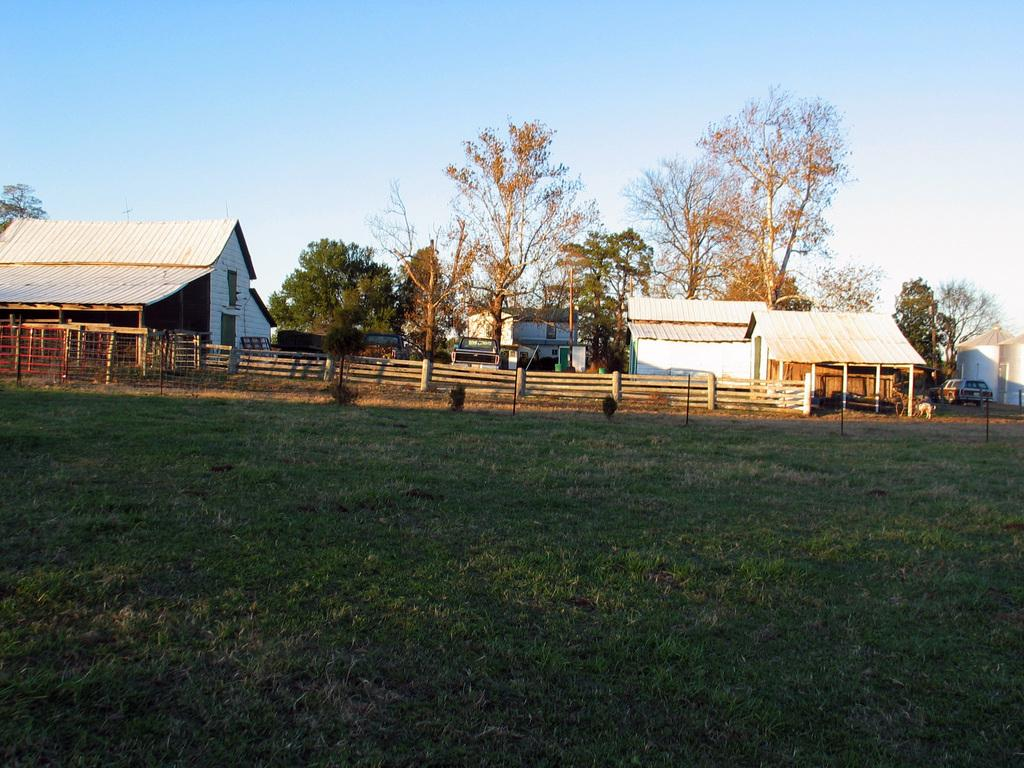What type of structures can be seen in the image? There are buildings and sheds in the image. What type of barrier is present in the image? There is a wooden fence in the image. What is visible on the ground in the image? The ground is visible in the image. What type of vegetation is present in the image? There are trees in the image. What type of transportation is present in the image? Motor vehicles are present in the image. What is visible in the sky in the image? The sky is visible in the image, and clouds are present. What type of rice is being cooked in the image? There is no rice present in the image. How loud is the quiet in the image? The concept of "quiet" is not something that can be quantified or measured in an image. 